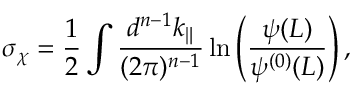Convert formula to latex. <formula><loc_0><loc_0><loc_500><loc_500>\sigma _ { \chi } = \frac { 1 } { 2 } \int \frac { d ^ { n - 1 } k _ { \| } } { ( 2 \pi ) ^ { n - 1 } } \ln \left ( \frac { \psi ( L ) } { \psi ^ { ( 0 ) } ( L ) } \right ) ,</formula> 